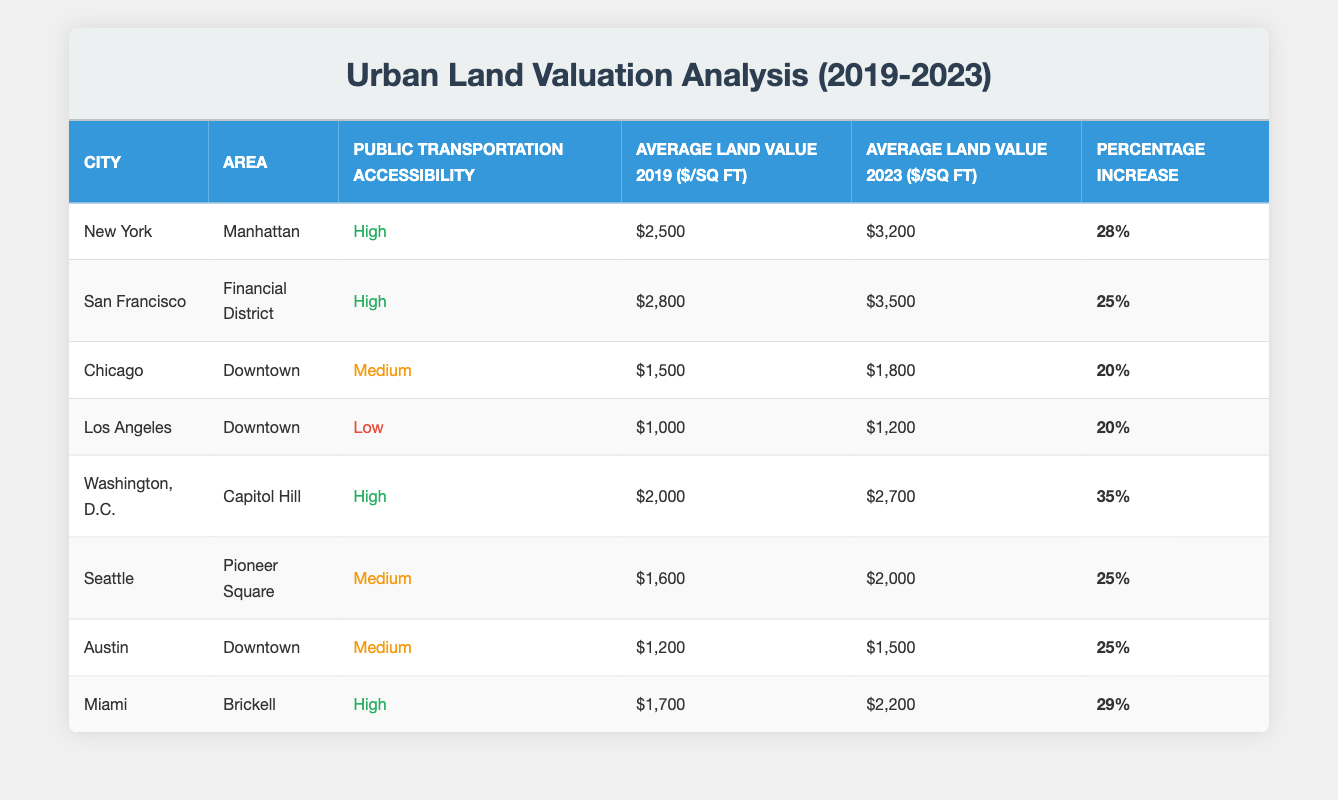What is the average land value in New York's Manhattan in 2023? According to the table, the average land value for New York, specifically Manhattan, in 2023 is $3,200 per square foot.
Answer: $3,200 Which area showed the highest percentage increase in land valuation from 2019 to 2023? To find this, I will look for the maximum percentage increase in the table. Washington, D.C. with a percentage increase of 35% has the highest increase among all listed areas.
Answer: Washington, D.C Is the average land value in Los Angeles in 2023 greater than $1,500? Looking at the table, the average land value in Los Angeles in 2023 is $1,200. Since $1,200 is less than $1,500, the answer is no.
Answer: No What is the total percentage increase of land valuation for areas with high public transportation accessibility? The areas with high accessibility are: Manhattan (28%), Financial District (25%), Capitol Hill (35%), and Brickell (29%). Adding these percentages gives 28 + 25 + 35 + 29 = 117%.
Answer: 117% Which cities had a medium level of public transportation accessibility? The table lists Chicago, Seattle, and Austin as having medium public transportation accessibility.
Answer: Chicago, Seattle, Austin What is the difference in average land value from 2019 to 2023 in Chicago? The average land value in Chicago in 2019 was $1,500 and in 2023 it is $1,800. The difference is calculated as $1,800 - $1,500 = $300.
Answer: $300 Is there any area with low public transportation accessibility that has a percentage increase above 20%? The table indicates that Los Angeles has a low accessibility rating but its percentage increase is 20%. Therefore, there are no areas with low accessibility that exceed 20%.
Answer: No What is the average land value in 2023 for all areas combined? To calculate the average land value in 2023, sum all values: (3200 + 3500 + 1800 + 1200 + 2700 + 2000 + 1500 + 2200) = 18600. There are 8 areas, so the average is 18600 / 8 = 2325.
Answer: $2,325 